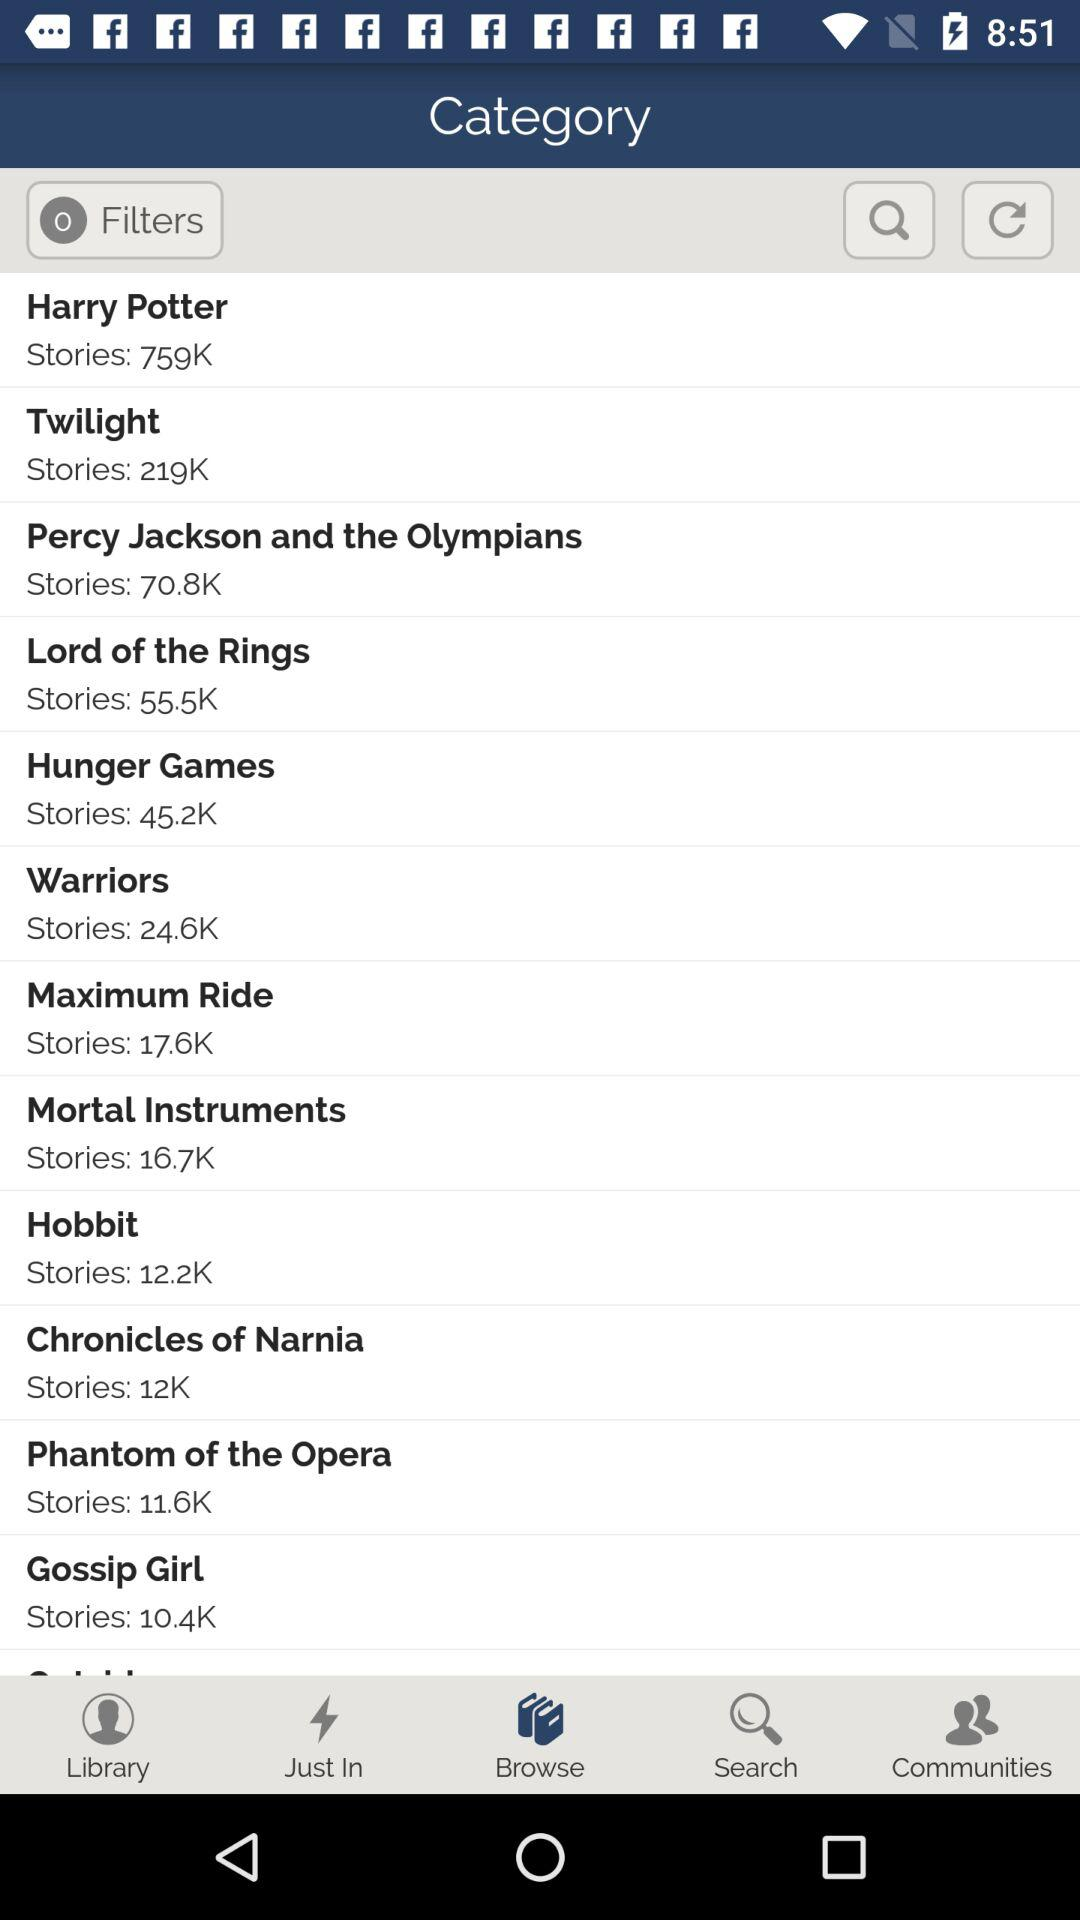How many notifications are there in "Communities"?
When the provided information is insufficient, respond with <no answer>. <no answer> 